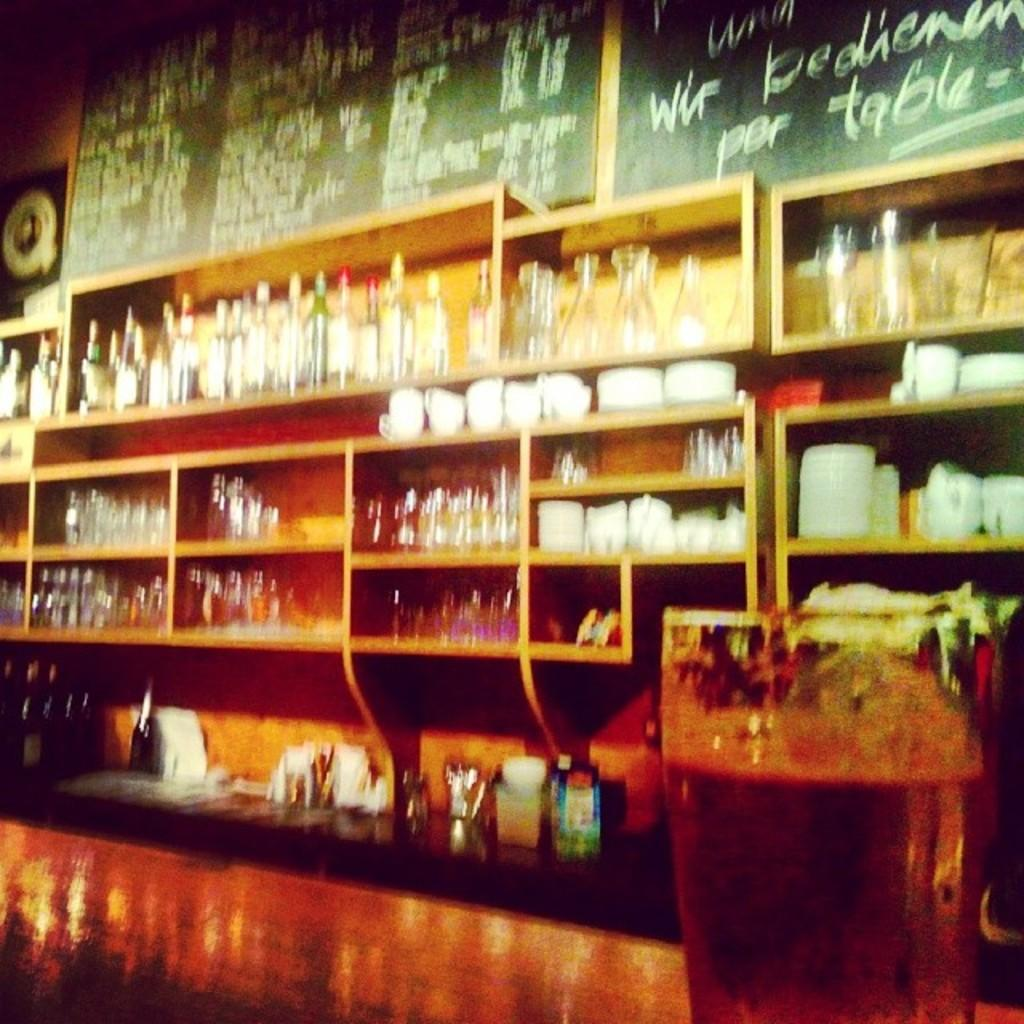<image>
Present a compact description of the photo's key features. a black board with a menu written in white chalk 